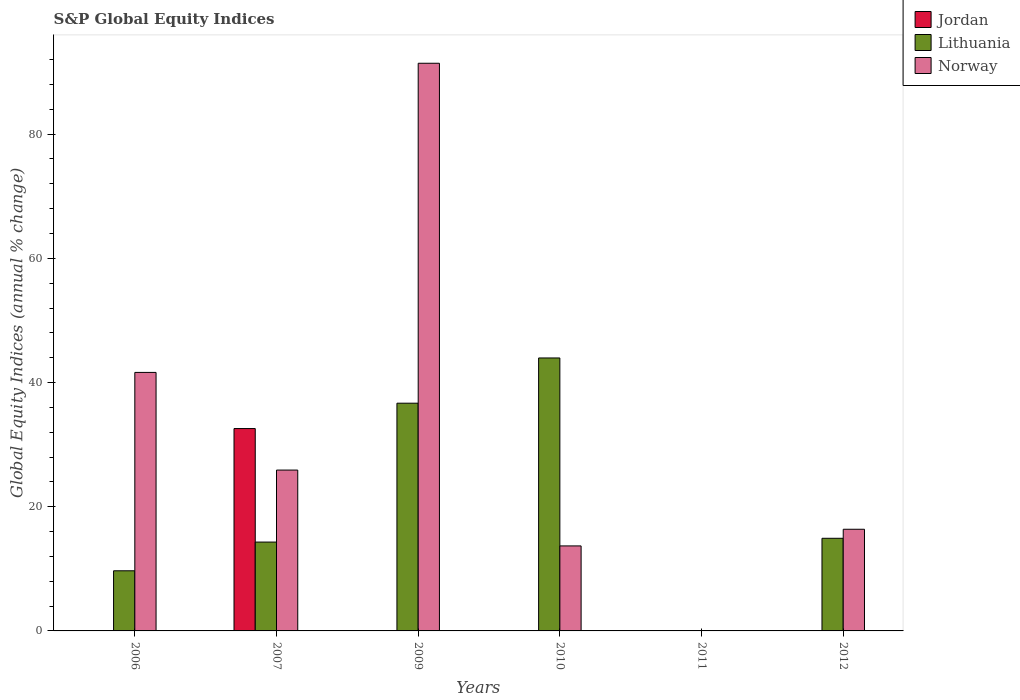Are the number of bars on each tick of the X-axis equal?
Your response must be concise. No. What is the global equity indices in Lithuania in 2010?
Offer a terse response. 43.96. Across all years, what is the maximum global equity indices in Jordan?
Provide a succinct answer. 32.59. What is the total global equity indices in Jordan in the graph?
Keep it short and to the point. 32.59. What is the difference between the global equity indices in Lithuania in 2010 and that in 2012?
Offer a terse response. 29.04. What is the difference between the global equity indices in Lithuania in 2009 and the global equity indices in Jordan in 2012?
Provide a succinct answer. 36.67. What is the average global equity indices in Lithuania per year?
Give a very brief answer. 19.92. In the year 2009, what is the difference between the global equity indices in Lithuania and global equity indices in Norway?
Keep it short and to the point. -54.74. What is the ratio of the global equity indices in Norway in 2007 to that in 2012?
Offer a terse response. 1.58. Is the difference between the global equity indices in Lithuania in 2010 and 2012 greater than the difference between the global equity indices in Norway in 2010 and 2012?
Provide a short and direct response. Yes. What is the difference between the highest and the second highest global equity indices in Lithuania?
Make the answer very short. 7.29. What is the difference between the highest and the lowest global equity indices in Lithuania?
Keep it short and to the point. 43.96. How many bars are there?
Your answer should be very brief. 11. Are all the bars in the graph horizontal?
Keep it short and to the point. No. What is the difference between two consecutive major ticks on the Y-axis?
Offer a very short reply. 20. Does the graph contain any zero values?
Your response must be concise. Yes. Where does the legend appear in the graph?
Make the answer very short. Top right. How are the legend labels stacked?
Keep it short and to the point. Vertical. What is the title of the graph?
Offer a terse response. S&P Global Equity Indices. Does "Monaco" appear as one of the legend labels in the graph?
Your answer should be compact. No. What is the label or title of the Y-axis?
Offer a terse response. Global Equity Indices (annual % change). What is the Global Equity Indices (annual % change) of Jordan in 2006?
Offer a terse response. 0. What is the Global Equity Indices (annual % change) in Lithuania in 2006?
Keep it short and to the point. 9.68. What is the Global Equity Indices (annual % change) of Norway in 2006?
Your response must be concise. 41.63. What is the Global Equity Indices (annual % change) in Jordan in 2007?
Keep it short and to the point. 32.59. What is the Global Equity Indices (annual % change) in Lithuania in 2007?
Make the answer very short. 14.31. What is the Global Equity Indices (annual % change) of Norway in 2007?
Give a very brief answer. 25.9. What is the Global Equity Indices (annual % change) of Lithuania in 2009?
Your answer should be compact. 36.67. What is the Global Equity Indices (annual % change) of Norway in 2009?
Offer a very short reply. 91.41. What is the Global Equity Indices (annual % change) of Jordan in 2010?
Provide a succinct answer. 0. What is the Global Equity Indices (annual % change) in Lithuania in 2010?
Give a very brief answer. 43.96. What is the Global Equity Indices (annual % change) of Norway in 2010?
Your answer should be very brief. 13.69. What is the Global Equity Indices (annual % change) in Jordan in 2011?
Your answer should be compact. 0. What is the Global Equity Indices (annual % change) of Lithuania in 2011?
Offer a very short reply. 0. What is the Global Equity Indices (annual % change) in Norway in 2011?
Give a very brief answer. 0. What is the Global Equity Indices (annual % change) in Jordan in 2012?
Offer a terse response. 0. What is the Global Equity Indices (annual % change) of Lithuania in 2012?
Make the answer very short. 14.92. What is the Global Equity Indices (annual % change) of Norway in 2012?
Offer a very short reply. 16.37. Across all years, what is the maximum Global Equity Indices (annual % change) of Jordan?
Your answer should be compact. 32.59. Across all years, what is the maximum Global Equity Indices (annual % change) in Lithuania?
Your answer should be very brief. 43.96. Across all years, what is the maximum Global Equity Indices (annual % change) in Norway?
Your answer should be very brief. 91.41. Across all years, what is the minimum Global Equity Indices (annual % change) in Lithuania?
Offer a very short reply. 0. What is the total Global Equity Indices (annual % change) of Jordan in the graph?
Offer a terse response. 32.59. What is the total Global Equity Indices (annual % change) in Lithuania in the graph?
Give a very brief answer. 119.54. What is the total Global Equity Indices (annual % change) of Norway in the graph?
Provide a succinct answer. 189.01. What is the difference between the Global Equity Indices (annual % change) of Lithuania in 2006 and that in 2007?
Your response must be concise. -4.62. What is the difference between the Global Equity Indices (annual % change) of Norway in 2006 and that in 2007?
Offer a very short reply. 15.73. What is the difference between the Global Equity Indices (annual % change) of Lithuania in 2006 and that in 2009?
Your response must be concise. -26.99. What is the difference between the Global Equity Indices (annual % change) of Norway in 2006 and that in 2009?
Provide a short and direct response. -49.78. What is the difference between the Global Equity Indices (annual % change) in Lithuania in 2006 and that in 2010?
Your response must be concise. -34.27. What is the difference between the Global Equity Indices (annual % change) in Norway in 2006 and that in 2010?
Your response must be concise. 27.94. What is the difference between the Global Equity Indices (annual % change) of Lithuania in 2006 and that in 2012?
Give a very brief answer. -5.23. What is the difference between the Global Equity Indices (annual % change) in Norway in 2006 and that in 2012?
Offer a terse response. 25.26. What is the difference between the Global Equity Indices (annual % change) of Lithuania in 2007 and that in 2009?
Your answer should be compact. -22.36. What is the difference between the Global Equity Indices (annual % change) in Norway in 2007 and that in 2009?
Ensure brevity in your answer.  -65.51. What is the difference between the Global Equity Indices (annual % change) of Lithuania in 2007 and that in 2010?
Give a very brief answer. -29.65. What is the difference between the Global Equity Indices (annual % change) in Norway in 2007 and that in 2010?
Ensure brevity in your answer.  12.21. What is the difference between the Global Equity Indices (annual % change) in Lithuania in 2007 and that in 2012?
Keep it short and to the point. -0.61. What is the difference between the Global Equity Indices (annual % change) of Norway in 2007 and that in 2012?
Provide a succinct answer. 9.53. What is the difference between the Global Equity Indices (annual % change) in Lithuania in 2009 and that in 2010?
Give a very brief answer. -7.29. What is the difference between the Global Equity Indices (annual % change) of Norway in 2009 and that in 2010?
Offer a terse response. 77.72. What is the difference between the Global Equity Indices (annual % change) in Lithuania in 2009 and that in 2012?
Make the answer very short. 21.75. What is the difference between the Global Equity Indices (annual % change) in Norway in 2009 and that in 2012?
Keep it short and to the point. 75.04. What is the difference between the Global Equity Indices (annual % change) in Lithuania in 2010 and that in 2012?
Offer a very short reply. 29.04. What is the difference between the Global Equity Indices (annual % change) in Norway in 2010 and that in 2012?
Your answer should be very brief. -2.68. What is the difference between the Global Equity Indices (annual % change) in Lithuania in 2006 and the Global Equity Indices (annual % change) in Norway in 2007?
Give a very brief answer. -16.22. What is the difference between the Global Equity Indices (annual % change) in Lithuania in 2006 and the Global Equity Indices (annual % change) in Norway in 2009?
Offer a very short reply. -81.73. What is the difference between the Global Equity Indices (annual % change) in Lithuania in 2006 and the Global Equity Indices (annual % change) in Norway in 2010?
Give a very brief answer. -4.01. What is the difference between the Global Equity Indices (annual % change) of Lithuania in 2006 and the Global Equity Indices (annual % change) of Norway in 2012?
Ensure brevity in your answer.  -6.69. What is the difference between the Global Equity Indices (annual % change) of Jordan in 2007 and the Global Equity Indices (annual % change) of Lithuania in 2009?
Give a very brief answer. -4.08. What is the difference between the Global Equity Indices (annual % change) of Jordan in 2007 and the Global Equity Indices (annual % change) of Norway in 2009?
Your answer should be very brief. -58.83. What is the difference between the Global Equity Indices (annual % change) in Lithuania in 2007 and the Global Equity Indices (annual % change) in Norway in 2009?
Offer a terse response. -77.11. What is the difference between the Global Equity Indices (annual % change) in Jordan in 2007 and the Global Equity Indices (annual % change) in Lithuania in 2010?
Ensure brevity in your answer.  -11.37. What is the difference between the Global Equity Indices (annual % change) of Jordan in 2007 and the Global Equity Indices (annual % change) of Norway in 2010?
Ensure brevity in your answer.  18.9. What is the difference between the Global Equity Indices (annual % change) of Lithuania in 2007 and the Global Equity Indices (annual % change) of Norway in 2010?
Offer a terse response. 0.62. What is the difference between the Global Equity Indices (annual % change) in Jordan in 2007 and the Global Equity Indices (annual % change) in Lithuania in 2012?
Give a very brief answer. 17.67. What is the difference between the Global Equity Indices (annual % change) in Jordan in 2007 and the Global Equity Indices (annual % change) in Norway in 2012?
Keep it short and to the point. 16.22. What is the difference between the Global Equity Indices (annual % change) of Lithuania in 2007 and the Global Equity Indices (annual % change) of Norway in 2012?
Your answer should be compact. -2.06. What is the difference between the Global Equity Indices (annual % change) of Lithuania in 2009 and the Global Equity Indices (annual % change) of Norway in 2010?
Your response must be concise. 22.98. What is the difference between the Global Equity Indices (annual % change) of Lithuania in 2009 and the Global Equity Indices (annual % change) of Norway in 2012?
Keep it short and to the point. 20.3. What is the difference between the Global Equity Indices (annual % change) in Lithuania in 2010 and the Global Equity Indices (annual % change) in Norway in 2012?
Offer a terse response. 27.59. What is the average Global Equity Indices (annual % change) in Jordan per year?
Provide a short and direct response. 5.43. What is the average Global Equity Indices (annual % change) in Lithuania per year?
Keep it short and to the point. 19.92. What is the average Global Equity Indices (annual % change) in Norway per year?
Give a very brief answer. 31.5. In the year 2006, what is the difference between the Global Equity Indices (annual % change) of Lithuania and Global Equity Indices (annual % change) of Norway?
Your answer should be very brief. -31.95. In the year 2007, what is the difference between the Global Equity Indices (annual % change) of Jordan and Global Equity Indices (annual % change) of Lithuania?
Your answer should be very brief. 18.28. In the year 2007, what is the difference between the Global Equity Indices (annual % change) in Jordan and Global Equity Indices (annual % change) in Norway?
Provide a short and direct response. 6.68. In the year 2007, what is the difference between the Global Equity Indices (annual % change) of Lithuania and Global Equity Indices (annual % change) of Norway?
Make the answer very short. -11.6. In the year 2009, what is the difference between the Global Equity Indices (annual % change) in Lithuania and Global Equity Indices (annual % change) in Norway?
Provide a succinct answer. -54.74. In the year 2010, what is the difference between the Global Equity Indices (annual % change) of Lithuania and Global Equity Indices (annual % change) of Norway?
Ensure brevity in your answer.  30.27. In the year 2012, what is the difference between the Global Equity Indices (annual % change) of Lithuania and Global Equity Indices (annual % change) of Norway?
Make the answer very short. -1.45. What is the ratio of the Global Equity Indices (annual % change) of Lithuania in 2006 to that in 2007?
Ensure brevity in your answer.  0.68. What is the ratio of the Global Equity Indices (annual % change) in Norway in 2006 to that in 2007?
Provide a short and direct response. 1.61. What is the ratio of the Global Equity Indices (annual % change) of Lithuania in 2006 to that in 2009?
Keep it short and to the point. 0.26. What is the ratio of the Global Equity Indices (annual % change) in Norway in 2006 to that in 2009?
Provide a short and direct response. 0.46. What is the ratio of the Global Equity Indices (annual % change) in Lithuania in 2006 to that in 2010?
Your answer should be very brief. 0.22. What is the ratio of the Global Equity Indices (annual % change) in Norway in 2006 to that in 2010?
Provide a succinct answer. 3.04. What is the ratio of the Global Equity Indices (annual % change) of Lithuania in 2006 to that in 2012?
Your answer should be compact. 0.65. What is the ratio of the Global Equity Indices (annual % change) in Norway in 2006 to that in 2012?
Ensure brevity in your answer.  2.54. What is the ratio of the Global Equity Indices (annual % change) of Lithuania in 2007 to that in 2009?
Your answer should be compact. 0.39. What is the ratio of the Global Equity Indices (annual % change) in Norway in 2007 to that in 2009?
Keep it short and to the point. 0.28. What is the ratio of the Global Equity Indices (annual % change) in Lithuania in 2007 to that in 2010?
Offer a terse response. 0.33. What is the ratio of the Global Equity Indices (annual % change) of Norway in 2007 to that in 2010?
Give a very brief answer. 1.89. What is the ratio of the Global Equity Indices (annual % change) of Lithuania in 2007 to that in 2012?
Make the answer very short. 0.96. What is the ratio of the Global Equity Indices (annual % change) of Norway in 2007 to that in 2012?
Offer a very short reply. 1.58. What is the ratio of the Global Equity Indices (annual % change) of Lithuania in 2009 to that in 2010?
Your response must be concise. 0.83. What is the ratio of the Global Equity Indices (annual % change) in Norway in 2009 to that in 2010?
Provide a succinct answer. 6.68. What is the ratio of the Global Equity Indices (annual % change) in Lithuania in 2009 to that in 2012?
Give a very brief answer. 2.46. What is the ratio of the Global Equity Indices (annual % change) of Norway in 2009 to that in 2012?
Provide a succinct answer. 5.58. What is the ratio of the Global Equity Indices (annual % change) in Lithuania in 2010 to that in 2012?
Give a very brief answer. 2.95. What is the ratio of the Global Equity Indices (annual % change) in Norway in 2010 to that in 2012?
Provide a succinct answer. 0.84. What is the difference between the highest and the second highest Global Equity Indices (annual % change) in Lithuania?
Keep it short and to the point. 7.29. What is the difference between the highest and the second highest Global Equity Indices (annual % change) of Norway?
Keep it short and to the point. 49.78. What is the difference between the highest and the lowest Global Equity Indices (annual % change) of Jordan?
Offer a terse response. 32.59. What is the difference between the highest and the lowest Global Equity Indices (annual % change) in Lithuania?
Your answer should be very brief. 43.96. What is the difference between the highest and the lowest Global Equity Indices (annual % change) in Norway?
Make the answer very short. 91.41. 